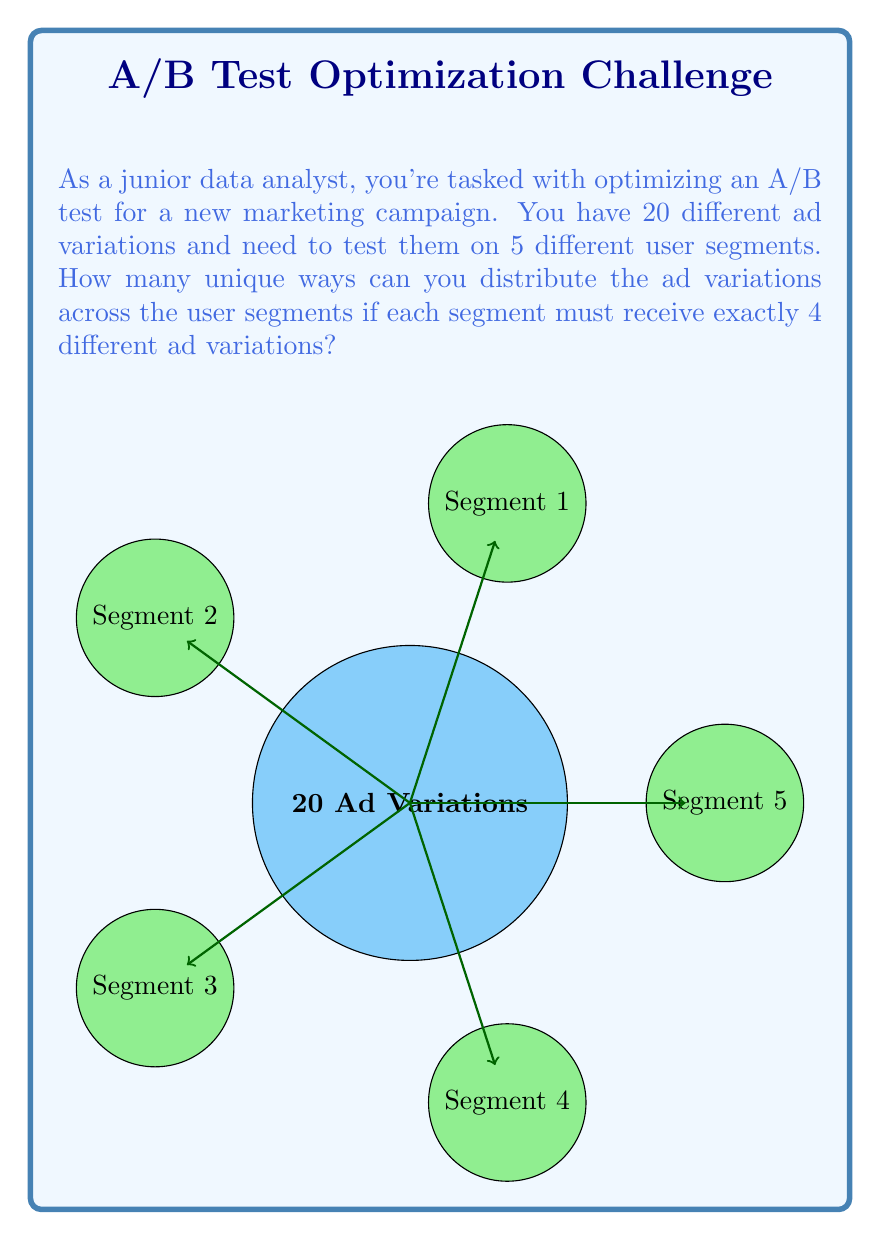Show me your answer to this math problem. Let's approach this step-by-step:

1) This is a combination problem. We need to select 4 ad variations for each of the 5 user segments.

2) For the first segment, we need to choose 4 ads out of 20. This can be done in $\binom{20}{4}$ ways.

3) For the second segment, we have 16 ads left, and we need to choose 4. This can be done in $\binom{16}{4}$ ways.

4) Continuing this pattern, for the third segment we have $\binom{12}{4}$ ways, for the fourth $\binom{8}{4}$, and for the last segment $\binom{4}{4}$ (which is 1, as there's only one way to choose the remaining 4 ads).

5) By the multiplication principle, the total number of ways to distribute the ads is:

   $$\binom{20}{4} \cdot \binom{16}{4} \cdot \binom{12}{4} \cdot \binom{8}{4} \cdot \binom{4}{4}$$

6) Let's calculate each combination:
   
   $\binom{20}{4} = 4845$
   $\binom{16}{4} = 1820$
   $\binom{12}{4} = 495$
   $\binom{8}{4} = 70$
   $\binom{4}{4} = 1$

7) Multiplying these together:

   $4845 \cdot 1820 \cdot 495 \cdot 70 \cdot 1 = 3,063,759,900,000$

Therefore, there are 3,063,759,900,000 unique ways to distribute the ad variations across the user segments.
Answer: 3,063,759,900,000 